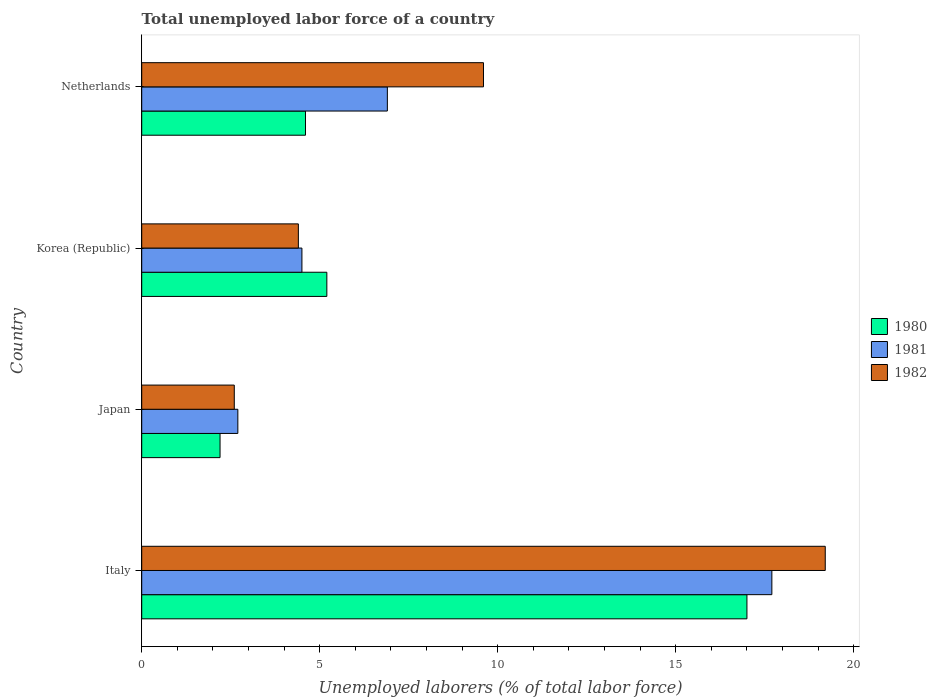How many groups of bars are there?
Make the answer very short. 4. Are the number of bars per tick equal to the number of legend labels?
Offer a terse response. Yes. Are the number of bars on each tick of the Y-axis equal?
Your response must be concise. Yes. How many bars are there on the 4th tick from the top?
Your answer should be compact. 3. How many bars are there on the 1st tick from the bottom?
Keep it short and to the point. 3. What is the label of the 1st group of bars from the top?
Your response must be concise. Netherlands. What is the total unemployed labor force in 1980 in Netherlands?
Offer a terse response. 4.6. Across all countries, what is the maximum total unemployed labor force in 1981?
Ensure brevity in your answer.  17.7. Across all countries, what is the minimum total unemployed labor force in 1980?
Make the answer very short. 2.2. What is the total total unemployed labor force in 1980 in the graph?
Offer a very short reply. 29. What is the difference between the total unemployed labor force in 1981 in Japan and that in Netherlands?
Make the answer very short. -4.2. What is the difference between the total unemployed labor force in 1980 in Japan and the total unemployed labor force in 1981 in Korea (Republic)?
Keep it short and to the point. -2.3. What is the average total unemployed labor force in 1982 per country?
Your response must be concise. 8.95. What is the difference between the total unemployed labor force in 1981 and total unemployed labor force in 1982 in Italy?
Your answer should be very brief. -1.5. What is the ratio of the total unemployed labor force in 1982 in Italy to that in Korea (Republic)?
Offer a very short reply. 4.36. Is the difference between the total unemployed labor force in 1981 in Japan and Netherlands greater than the difference between the total unemployed labor force in 1982 in Japan and Netherlands?
Your response must be concise. Yes. What is the difference between the highest and the second highest total unemployed labor force in 1982?
Your answer should be compact. 9.6. What is the difference between the highest and the lowest total unemployed labor force in 1980?
Make the answer very short. 14.8. Is the sum of the total unemployed labor force in 1982 in Japan and Netherlands greater than the maximum total unemployed labor force in 1981 across all countries?
Give a very brief answer. No. What does the 3rd bar from the top in Korea (Republic) represents?
Your answer should be compact. 1980. Is it the case that in every country, the sum of the total unemployed labor force in 1981 and total unemployed labor force in 1982 is greater than the total unemployed labor force in 1980?
Your response must be concise. Yes. What is the difference between two consecutive major ticks on the X-axis?
Provide a succinct answer. 5. Where does the legend appear in the graph?
Your answer should be compact. Center right. What is the title of the graph?
Ensure brevity in your answer.  Total unemployed labor force of a country. What is the label or title of the X-axis?
Your answer should be compact. Unemployed laborers (% of total labor force). What is the label or title of the Y-axis?
Keep it short and to the point. Country. What is the Unemployed laborers (% of total labor force) of 1980 in Italy?
Keep it short and to the point. 17. What is the Unemployed laborers (% of total labor force) in 1981 in Italy?
Your answer should be very brief. 17.7. What is the Unemployed laborers (% of total labor force) of 1982 in Italy?
Provide a succinct answer. 19.2. What is the Unemployed laborers (% of total labor force) of 1980 in Japan?
Give a very brief answer. 2.2. What is the Unemployed laborers (% of total labor force) in 1981 in Japan?
Offer a very short reply. 2.7. What is the Unemployed laborers (% of total labor force) of 1982 in Japan?
Provide a succinct answer. 2.6. What is the Unemployed laborers (% of total labor force) in 1980 in Korea (Republic)?
Offer a very short reply. 5.2. What is the Unemployed laborers (% of total labor force) of 1982 in Korea (Republic)?
Your answer should be compact. 4.4. What is the Unemployed laborers (% of total labor force) of 1980 in Netherlands?
Offer a very short reply. 4.6. What is the Unemployed laborers (% of total labor force) of 1981 in Netherlands?
Make the answer very short. 6.9. What is the Unemployed laborers (% of total labor force) in 1982 in Netherlands?
Your answer should be compact. 9.6. Across all countries, what is the maximum Unemployed laborers (% of total labor force) in 1980?
Your answer should be very brief. 17. Across all countries, what is the maximum Unemployed laborers (% of total labor force) of 1981?
Give a very brief answer. 17.7. Across all countries, what is the maximum Unemployed laborers (% of total labor force) of 1982?
Ensure brevity in your answer.  19.2. Across all countries, what is the minimum Unemployed laborers (% of total labor force) in 1980?
Offer a terse response. 2.2. Across all countries, what is the minimum Unemployed laborers (% of total labor force) in 1981?
Ensure brevity in your answer.  2.7. Across all countries, what is the minimum Unemployed laborers (% of total labor force) of 1982?
Keep it short and to the point. 2.6. What is the total Unemployed laborers (% of total labor force) in 1980 in the graph?
Provide a short and direct response. 29. What is the total Unemployed laborers (% of total labor force) in 1981 in the graph?
Your answer should be compact. 31.8. What is the total Unemployed laborers (% of total labor force) in 1982 in the graph?
Your answer should be very brief. 35.8. What is the difference between the Unemployed laborers (% of total labor force) in 1980 in Italy and that in Japan?
Offer a terse response. 14.8. What is the difference between the Unemployed laborers (% of total labor force) of 1981 in Italy and that in Netherlands?
Provide a succinct answer. 10.8. What is the difference between the Unemployed laborers (% of total labor force) of 1982 in Japan and that in Netherlands?
Your answer should be very brief. -7. What is the difference between the Unemployed laborers (% of total labor force) of 1981 in Korea (Republic) and that in Netherlands?
Your response must be concise. -2.4. What is the difference between the Unemployed laborers (% of total labor force) of 1982 in Korea (Republic) and that in Netherlands?
Your answer should be very brief. -5.2. What is the difference between the Unemployed laborers (% of total labor force) in 1980 in Italy and the Unemployed laborers (% of total labor force) in 1981 in Japan?
Make the answer very short. 14.3. What is the difference between the Unemployed laborers (% of total labor force) of 1981 in Italy and the Unemployed laborers (% of total labor force) of 1982 in Japan?
Keep it short and to the point. 15.1. What is the difference between the Unemployed laborers (% of total labor force) of 1980 in Italy and the Unemployed laborers (% of total labor force) of 1982 in Korea (Republic)?
Ensure brevity in your answer.  12.6. What is the difference between the Unemployed laborers (% of total labor force) in 1980 in Italy and the Unemployed laborers (% of total labor force) in 1981 in Netherlands?
Your answer should be very brief. 10.1. What is the difference between the Unemployed laborers (% of total labor force) in 1980 in Italy and the Unemployed laborers (% of total labor force) in 1982 in Netherlands?
Your answer should be very brief. 7.4. What is the difference between the Unemployed laborers (% of total labor force) of 1980 in Japan and the Unemployed laborers (% of total labor force) of 1982 in Korea (Republic)?
Give a very brief answer. -2.2. What is the difference between the Unemployed laborers (% of total labor force) of 1981 in Japan and the Unemployed laborers (% of total labor force) of 1982 in Korea (Republic)?
Your answer should be compact. -1.7. What is the difference between the Unemployed laborers (% of total labor force) in 1980 in Japan and the Unemployed laborers (% of total labor force) in 1981 in Netherlands?
Provide a short and direct response. -4.7. What is the difference between the Unemployed laborers (% of total labor force) of 1980 in Japan and the Unemployed laborers (% of total labor force) of 1982 in Netherlands?
Ensure brevity in your answer.  -7.4. What is the difference between the Unemployed laborers (% of total labor force) in 1980 in Korea (Republic) and the Unemployed laborers (% of total labor force) in 1981 in Netherlands?
Keep it short and to the point. -1.7. What is the difference between the Unemployed laborers (% of total labor force) in 1980 in Korea (Republic) and the Unemployed laborers (% of total labor force) in 1982 in Netherlands?
Your response must be concise. -4.4. What is the average Unemployed laborers (% of total labor force) in 1980 per country?
Your answer should be compact. 7.25. What is the average Unemployed laborers (% of total labor force) of 1981 per country?
Give a very brief answer. 7.95. What is the average Unemployed laborers (% of total labor force) in 1982 per country?
Offer a terse response. 8.95. What is the difference between the Unemployed laborers (% of total labor force) in 1981 and Unemployed laborers (% of total labor force) in 1982 in Italy?
Offer a terse response. -1.5. What is the difference between the Unemployed laborers (% of total labor force) in 1980 and Unemployed laborers (% of total labor force) in 1981 in Japan?
Your answer should be very brief. -0.5. What is the difference between the Unemployed laborers (% of total labor force) in 1981 and Unemployed laborers (% of total labor force) in 1982 in Japan?
Offer a very short reply. 0.1. What is the difference between the Unemployed laborers (% of total labor force) in 1980 and Unemployed laborers (% of total labor force) in 1981 in Korea (Republic)?
Offer a very short reply. 0.7. What is the difference between the Unemployed laborers (% of total labor force) of 1980 and Unemployed laborers (% of total labor force) of 1982 in Korea (Republic)?
Your answer should be very brief. 0.8. What is the difference between the Unemployed laborers (% of total labor force) in 1980 and Unemployed laborers (% of total labor force) in 1981 in Netherlands?
Offer a very short reply. -2.3. What is the difference between the Unemployed laborers (% of total labor force) in 1981 and Unemployed laborers (% of total labor force) in 1982 in Netherlands?
Offer a terse response. -2.7. What is the ratio of the Unemployed laborers (% of total labor force) in 1980 in Italy to that in Japan?
Your response must be concise. 7.73. What is the ratio of the Unemployed laborers (% of total labor force) in 1981 in Italy to that in Japan?
Your answer should be very brief. 6.56. What is the ratio of the Unemployed laborers (% of total labor force) of 1982 in Italy to that in Japan?
Provide a succinct answer. 7.38. What is the ratio of the Unemployed laborers (% of total labor force) of 1980 in Italy to that in Korea (Republic)?
Ensure brevity in your answer.  3.27. What is the ratio of the Unemployed laborers (% of total labor force) in 1981 in Italy to that in Korea (Republic)?
Keep it short and to the point. 3.93. What is the ratio of the Unemployed laborers (% of total labor force) in 1982 in Italy to that in Korea (Republic)?
Make the answer very short. 4.36. What is the ratio of the Unemployed laborers (% of total labor force) of 1980 in Italy to that in Netherlands?
Give a very brief answer. 3.7. What is the ratio of the Unemployed laborers (% of total labor force) in 1981 in Italy to that in Netherlands?
Ensure brevity in your answer.  2.57. What is the ratio of the Unemployed laborers (% of total labor force) in 1982 in Italy to that in Netherlands?
Provide a succinct answer. 2. What is the ratio of the Unemployed laborers (% of total labor force) of 1980 in Japan to that in Korea (Republic)?
Make the answer very short. 0.42. What is the ratio of the Unemployed laborers (% of total labor force) in 1982 in Japan to that in Korea (Republic)?
Offer a very short reply. 0.59. What is the ratio of the Unemployed laborers (% of total labor force) of 1980 in Japan to that in Netherlands?
Offer a very short reply. 0.48. What is the ratio of the Unemployed laborers (% of total labor force) in 1981 in Japan to that in Netherlands?
Your response must be concise. 0.39. What is the ratio of the Unemployed laborers (% of total labor force) of 1982 in Japan to that in Netherlands?
Keep it short and to the point. 0.27. What is the ratio of the Unemployed laborers (% of total labor force) in 1980 in Korea (Republic) to that in Netherlands?
Keep it short and to the point. 1.13. What is the ratio of the Unemployed laborers (% of total labor force) of 1981 in Korea (Republic) to that in Netherlands?
Your response must be concise. 0.65. What is the ratio of the Unemployed laborers (% of total labor force) in 1982 in Korea (Republic) to that in Netherlands?
Your response must be concise. 0.46. What is the difference between the highest and the second highest Unemployed laborers (% of total labor force) of 1982?
Your answer should be very brief. 9.6. What is the difference between the highest and the lowest Unemployed laborers (% of total labor force) in 1982?
Your answer should be compact. 16.6. 